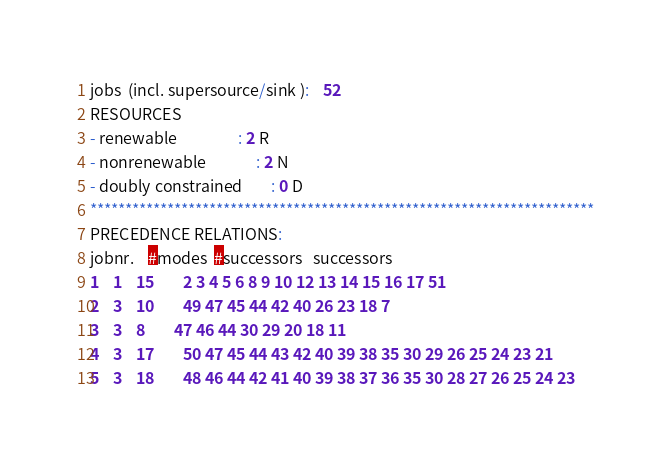<code> <loc_0><loc_0><loc_500><loc_500><_ObjectiveC_>jobs  (incl. supersource/sink ):	52
RESOURCES
- renewable                 : 2 R
- nonrenewable              : 2 N
- doubly constrained        : 0 D
************************************************************************
PRECEDENCE RELATIONS:
jobnr.    #modes  #successors   successors
1	1	15		2 3 4 5 6 8 9 10 12 13 14 15 16 17 51 
2	3	10		49 47 45 44 42 40 26 23 18 7 
3	3	8		47 46 44 30 29 20 18 11 
4	3	17		50 47 45 44 43 42 40 39 38 35 30 29 26 25 24 23 21 
5	3	18		48 46 44 42 41 40 39 38 37 36 35 30 28 27 26 25 24 23 </code> 